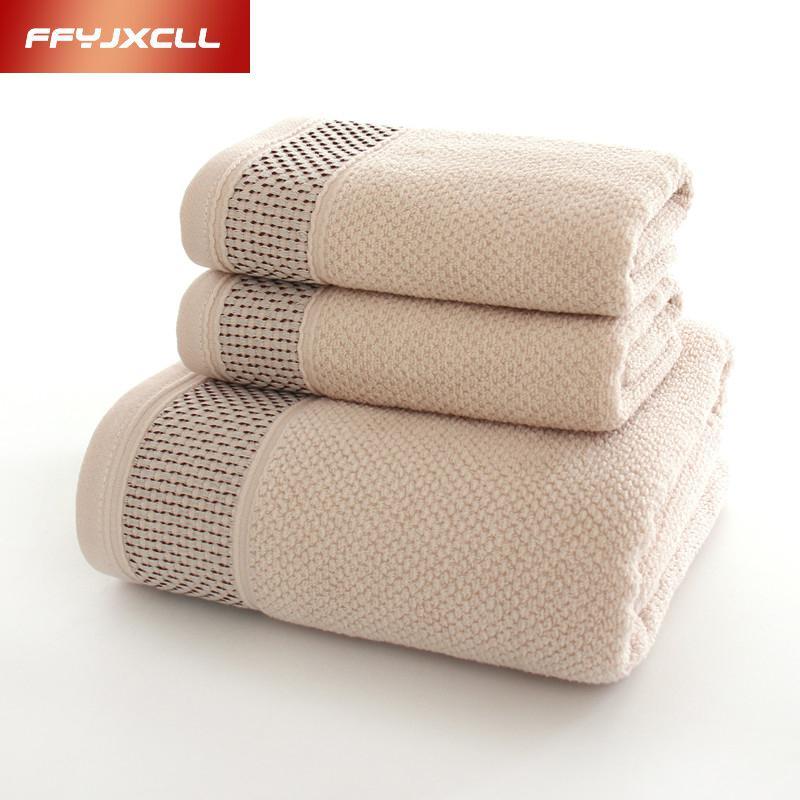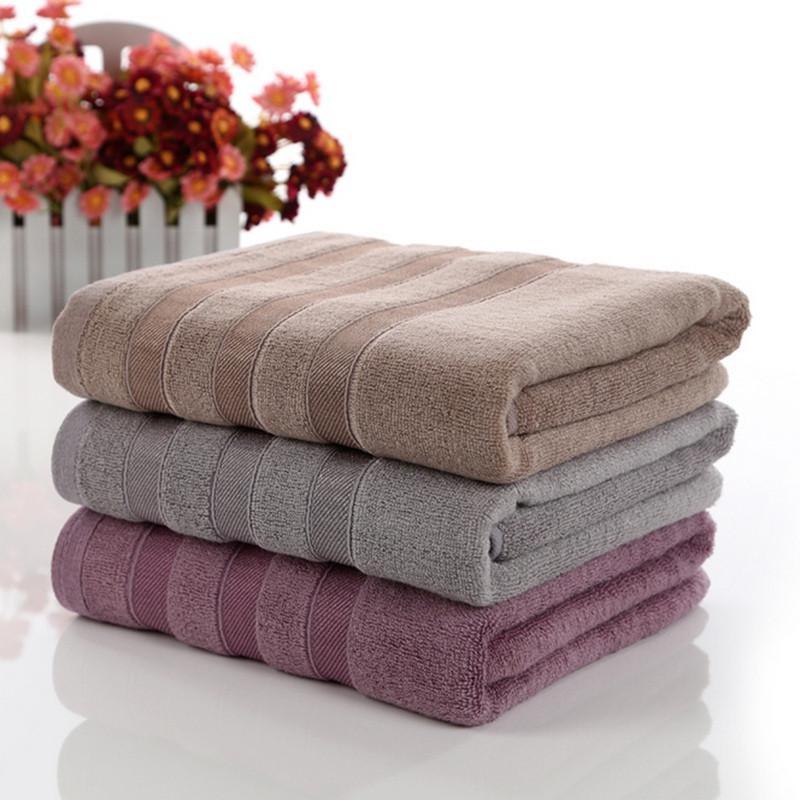The first image is the image on the left, the second image is the image on the right. For the images displayed, is the sentence "There are three folded towels on the right image." factually correct? Answer yes or no. Yes. 